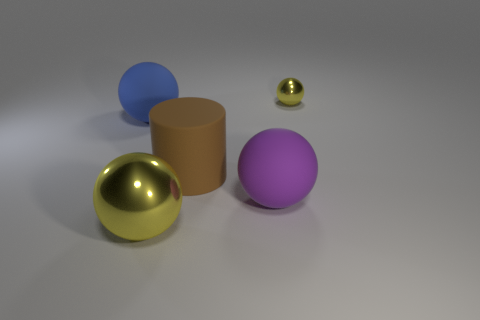There is a thing behind the blue rubber object; does it have the same size as the yellow object on the left side of the tiny object?
Your answer should be very brief. No. What number of other objects are the same size as the purple rubber sphere?
Offer a terse response. 3. What size is the ball that is both behind the large cylinder and in front of the small ball?
Offer a very short reply. Large. How many other things are there of the same shape as the big brown object?
Offer a very short reply. 0. What number of other objects are there of the same material as the tiny yellow object?
Your answer should be compact. 1. What size is the other matte thing that is the same shape as the big blue thing?
Give a very brief answer. Large. Is the color of the cylinder the same as the tiny ball?
Your response must be concise. No. What is the color of the sphere that is on the right side of the blue rubber object and behind the rubber cylinder?
Your answer should be very brief. Yellow. What number of things are either spheres to the left of the tiny yellow metallic thing or yellow balls?
Keep it short and to the point. 4. What color is the other tiny object that is the same shape as the blue rubber thing?
Keep it short and to the point. Yellow. 